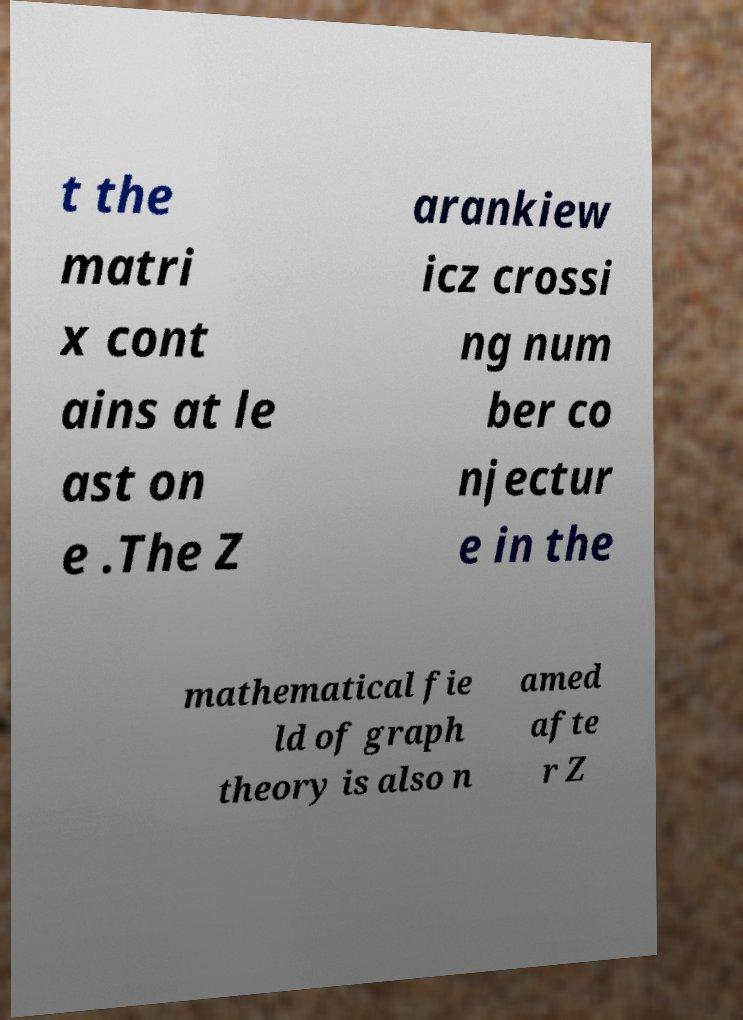For documentation purposes, I need the text within this image transcribed. Could you provide that? t the matri x cont ains at le ast on e .The Z arankiew icz crossi ng num ber co njectur e in the mathematical fie ld of graph theory is also n amed afte r Z 